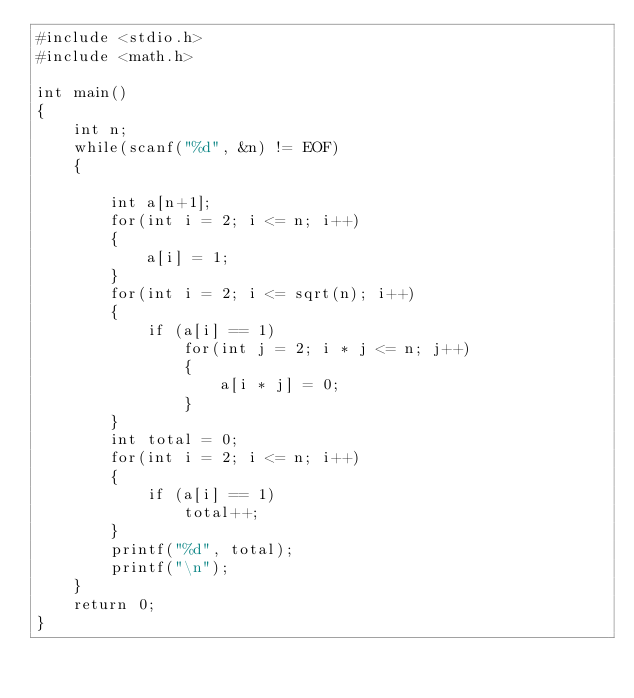Convert code to text. <code><loc_0><loc_0><loc_500><loc_500><_C_>#include <stdio.h>
#include <math.h>

int main()
{
    int n;
    while(scanf("%d", &n) != EOF)
    {

        int a[n+1];
        for(int i = 2; i <= n; i++)
        {
            a[i] = 1;
        }
        for(int i = 2; i <= sqrt(n); i++)
        {
            if (a[i] == 1)
                for(int j = 2; i * j <= n; j++)
                {
                    a[i * j] = 0;
                }
        }
        int total = 0;
        for(int i = 2; i <= n; i++)
        {
            if (a[i] == 1)
                total++;
        }
        printf("%d", total);
        printf("\n");
    }
    return 0;
}


</code> 